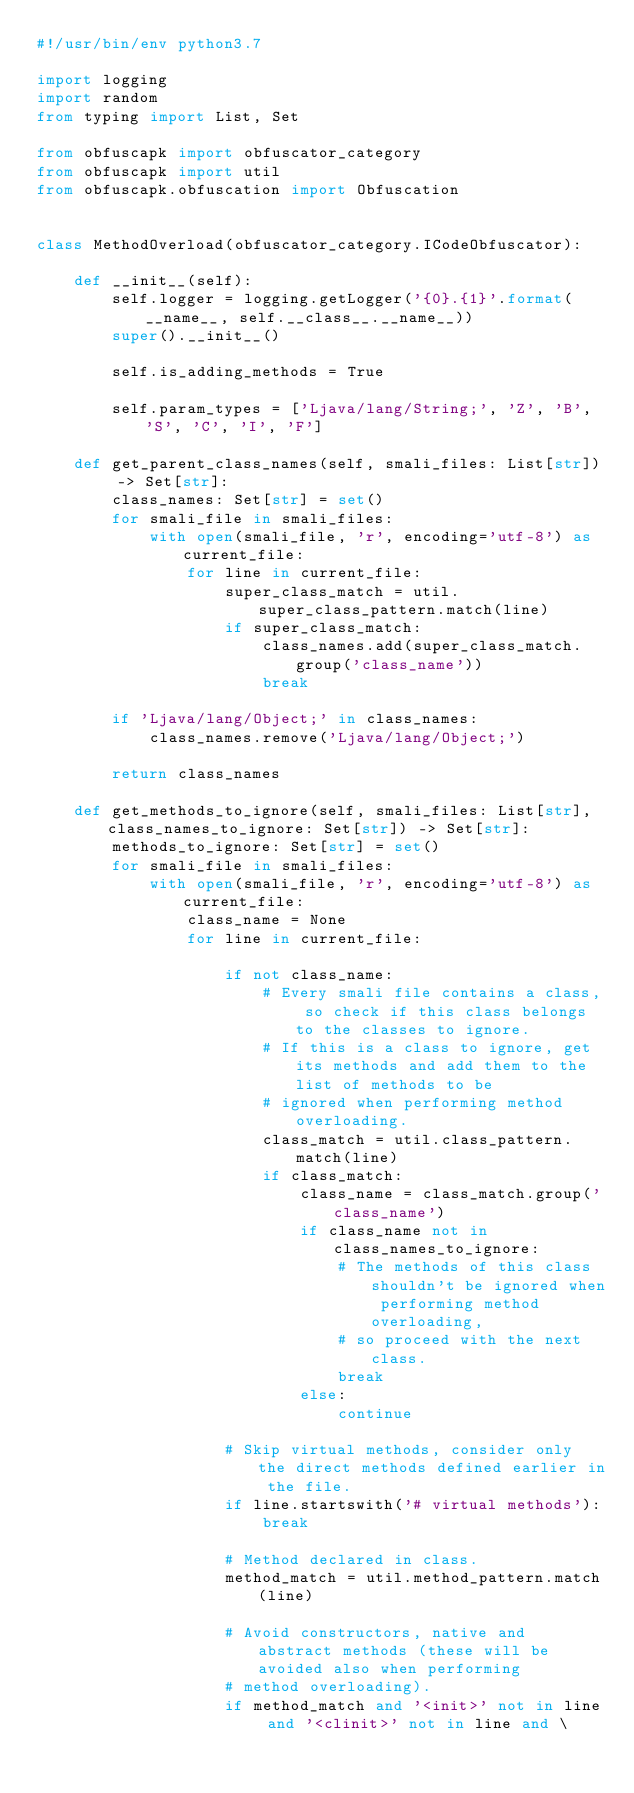Convert code to text. <code><loc_0><loc_0><loc_500><loc_500><_Python_>#!/usr/bin/env python3.7

import logging
import random
from typing import List, Set

from obfuscapk import obfuscator_category
from obfuscapk import util
from obfuscapk.obfuscation import Obfuscation


class MethodOverload(obfuscator_category.ICodeObfuscator):

    def __init__(self):
        self.logger = logging.getLogger('{0}.{1}'.format(__name__, self.__class__.__name__))
        super().__init__()

        self.is_adding_methods = True

        self.param_types = ['Ljava/lang/String;', 'Z', 'B', 'S', 'C', 'I', 'F']

    def get_parent_class_names(self, smali_files: List[str]) -> Set[str]:
        class_names: Set[str] = set()
        for smali_file in smali_files:
            with open(smali_file, 'r', encoding='utf-8') as current_file:
                for line in current_file:
                    super_class_match = util.super_class_pattern.match(line)
                    if super_class_match:
                        class_names.add(super_class_match.group('class_name'))
                        break

        if 'Ljava/lang/Object;' in class_names:
            class_names.remove('Ljava/lang/Object;')

        return class_names

    def get_methods_to_ignore(self, smali_files: List[str], class_names_to_ignore: Set[str]) -> Set[str]:
        methods_to_ignore: Set[str] = set()
        for smali_file in smali_files:
            with open(smali_file, 'r', encoding='utf-8') as current_file:
                class_name = None
                for line in current_file:

                    if not class_name:
                        # Every smali file contains a class, so check if this class belongs to the classes to ignore.
                        # If this is a class to ignore, get its methods and add them to the list of methods to be
                        # ignored when performing method overloading.
                        class_match = util.class_pattern.match(line)
                        if class_match:
                            class_name = class_match.group('class_name')
                            if class_name not in class_names_to_ignore:
                                # The methods of this class shouldn't be ignored when performing method overloading,
                                # so proceed with the next class.
                                break
                            else:
                                continue

                    # Skip virtual methods, consider only the direct methods defined earlier in the file.
                    if line.startswith('# virtual methods'):
                        break

                    # Method declared in class.
                    method_match = util.method_pattern.match(line)

                    # Avoid constructors, native and abstract methods (these will be avoided also when performing
                    # method overloading).
                    if method_match and '<init>' not in line and '<clinit>' not in line and \</code> 